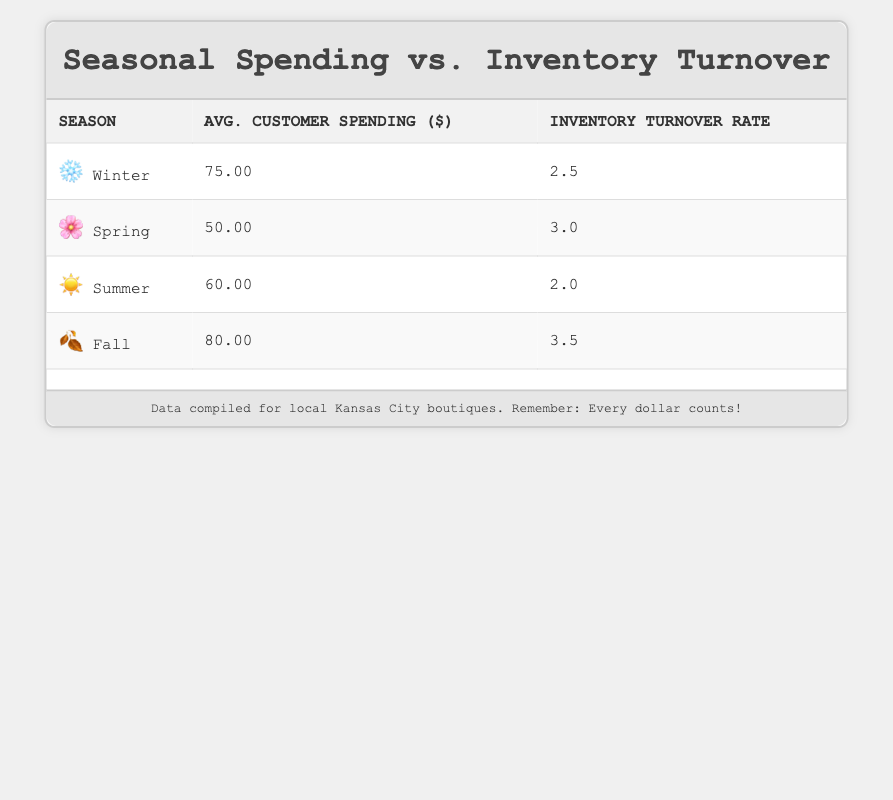What is the average customer spending during Fall? The table shows that the average customer spending in Fall is listed as 80.00.
Answer: 80.00 Which season has the highest inventory turnover rate? The highest inventory turnover rate can be found in the Fall season, which is 3.5.
Answer: Fall What is the difference in average customer spending between Winter and Spring? Average customer spending in Winter is 75.00 and in Spring is 50.00. The difference is 75.00 - 50.00 = 25.00.
Answer: 25.00 Is the average customer spending higher in Winter compared to Summer? The average customer spending in Winter is 75.00 and in Summer is 60.00. Since 75.00 is greater than 60.00, the statement is true.
Answer: Yes What is the average inventory turnover rate across all seasons? The inventory turnover rates are 2.5 (Winter), 3.0 (Spring), 2.0 (Summer), and 3.5 (Fall). Adding these gives 2.5 + 3.0 + 2.0 + 3.5 = 11.0, and dividing by 4 seasons gives an average of 11.0 / 4 = 2.75.
Answer: 2.75 Which season has lower average customer spending than the average of all seasons? First, calculate the average customer spending: (75.00 + 50.00 + 60.00 + 80.00) / 4 = 65.00. The spending in Spring, which is 50.00, is lower than this average.
Answer: Spring What is the seasonal trend in customer spending from Winter to Fall? Reviewing the customer spending: Winter (75.00), Spring (50.00), Summer (60.00), and Fall (80.00), we see an initial decrease from Winter to Spring, a slight increase in Summer, and a rise again in Fall, indicating a general upward trend overall.
Answer: Upward trend Are customers spending more on average in the warmer months (Spring and Summer) compared to the colder months (Winter and Fall)? Summer and Spring customer spending is 60.00 + 50.00 = 110.00. Winter and Fall customer spending is 75.00 + 80.00 = 155.00. Since 110.00 is less than 155.00, customers are spending less on average in the warmer months.
Answer: No 